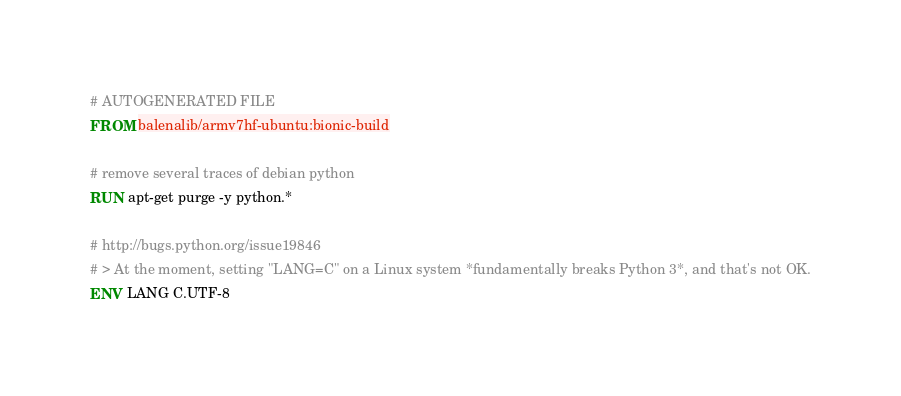<code> <loc_0><loc_0><loc_500><loc_500><_Dockerfile_># AUTOGENERATED FILE
FROM balenalib/armv7hf-ubuntu:bionic-build

# remove several traces of debian python
RUN apt-get purge -y python.*

# http://bugs.python.org/issue19846
# > At the moment, setting "LANG=C" on a Linux system *fundamentally breaks Python 3*, and that's not OK.
ENV LANG C.UTF-8
</code> 